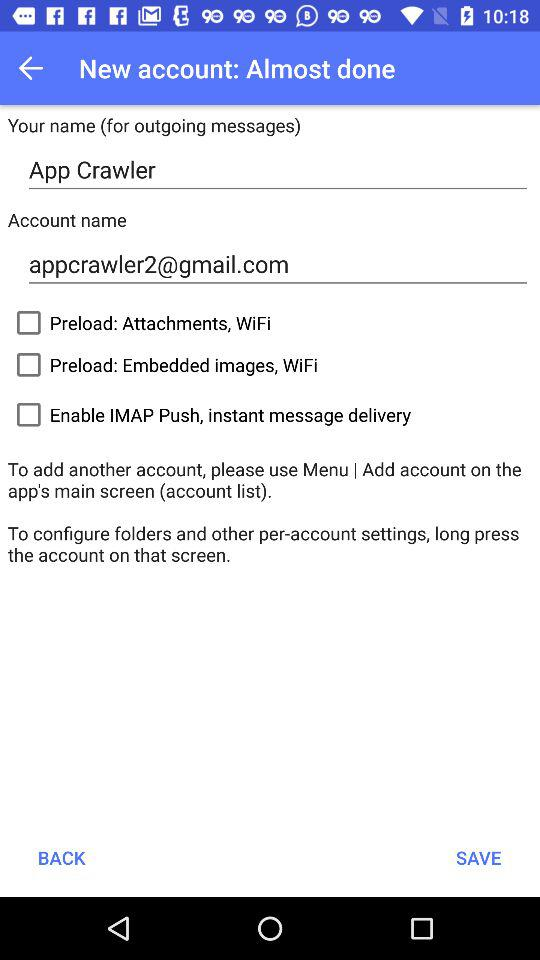What is the status of "Preload: Attachments, WIFI"? The status is "off". 